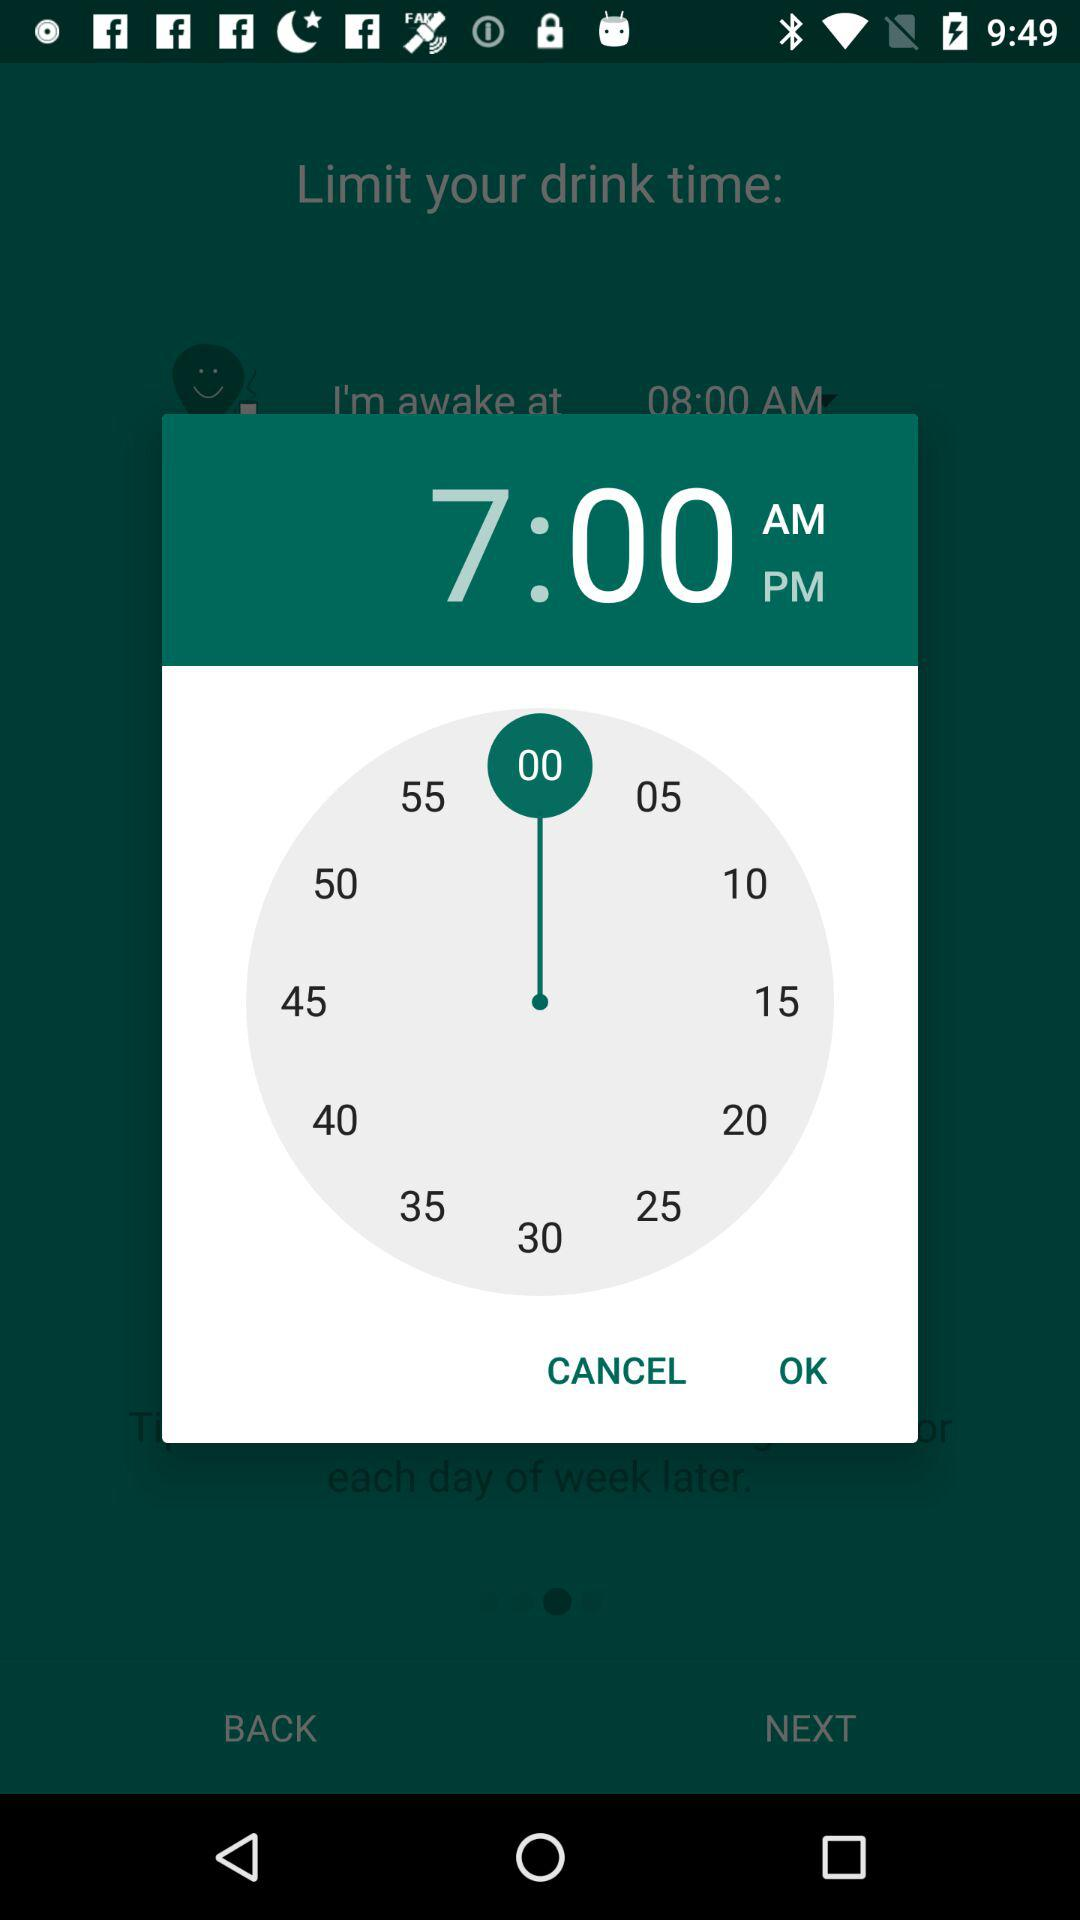What is the set time? The set time is 7:00 AM. 